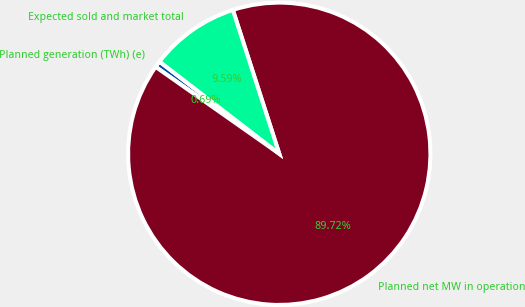Convert chart. <chart><loc_0><loc_0><loc_500><loc_500><pie_chart><fcel>Planned generation (TWh) (e)<fcel>Planned net MW in operation<fcel>Expected sold and market total<nl><fcel>0.69%<fcel>89.72%<fcel>9.59%<nl></chart> 